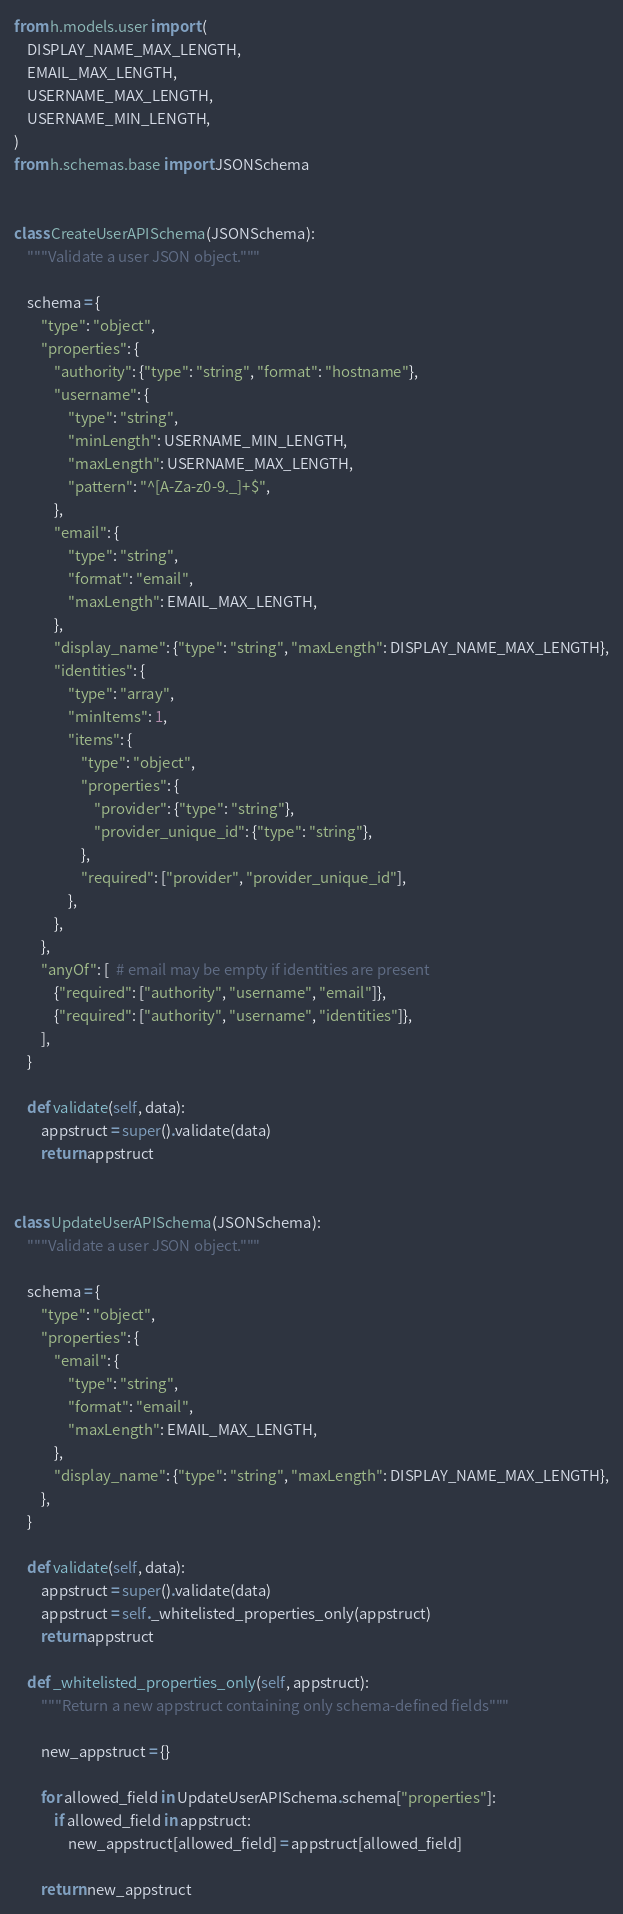<code> <loc_0><loc_0><loc_500><loc_500><_Python_>from h.models.user import (
    DISPLAY_NAME_MAX_LENGTH,
    EMAIL_MAX_LENGTH,
    USERNAME_MAX_LENGTH,
    USERNAME_MIN_LENGTH,
)
from h.schemas.base import JSONSchema


class CreateUserAPISchema(JSONSchema):
    """Validate a user JSON object."""

    schema = {
        "type": "object",
        "properties": {
            "authority": {"type": "string", "format": "hostname"},
            "username": {
                "type": "string",
                "minLength": USERNAME_MIN_LENGTH,
                "maxLength": USERNAME_MAX_LENGTH,
                "pattern": "^[A-Za-z0-9._]+$",
            },
            "email": {
                "type": "string",
                "format": "email",
                "maxLength": EMAIL_MAX_LENGTH,
            },
            "display_name": {"type": "string", "maxLength": DISPLAY_NAME_MAX_LENGTH},
            "identities": {
                "type": "array",
                "minItems": 1,
                "items": {
                    "type": "object",
                    "properties": {
                        "provider": {"type": "string"},
                        "provider_unique_id": {"type": "string"},
                    },
                    "required": ["provider", "provider_unique_id"],
                },
            },
        },
        "anyOf": [  # email may be empty if identities are present
            {"required": ["authority", "username", "email"]},
            {"required": ["authority", "username", "identities"]},
        ],
    }

    def validate(self, data):
        appstruct = super().validate(data)
        return appstruct


class UpdateUserAPISchema(JSONSchema):
    """Validate a user JSON object."""

    schema = {
        "type": "object",
        "properties": {
            "email": {
                "type": "string",
                "format": "email",
                "maxLength": EMAIL_MAX_LENGTH,
            },
            "display_name": {"type": "string", "maxLength": DISPLAY_NAME_MAX_LENGTH},
        },
    }

    def validate(self, data):
        appstruct = super().validate(data)
        appstruct = self._whitelisted_properties_only(appstruct)
        return appstruct

    def _whitelisted_properties_only(self, appstruct):
        """Return a new appstruct containing only schema-defined fields"""

        new_appstruct = {}

        for allowed_field in UpdateUserAPISchema.schema["properties"]:
            if allowed_field in appstruct:
                new_appstruct[allowed_field] = appstruct[allowed_field]

        return new_appstruct
</code> 